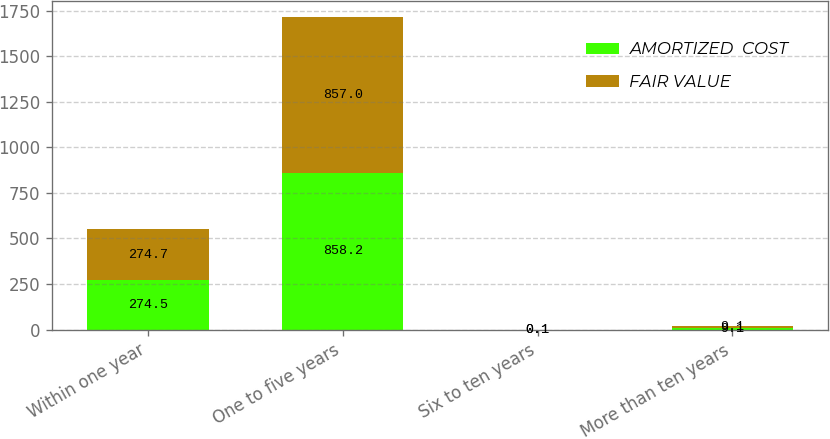Convert chart to OTSL. <chart><loc_0><loc_0><loc_500><loc_500><stacked_bar_chart><ecel><fcel>Within one year<fcel>One to five years<fcel>Six to ten years<fcel>More than ten years<nl><fcel>AMORTIZED  COST<fcel>274.5<fcel>858.2<fcel>0.1<fcel>9.1<nl><fcel>FAIR VALUE<fcel>274.7<fcel>857<fcel>0.1<fcel>9.1<nl></chart> 